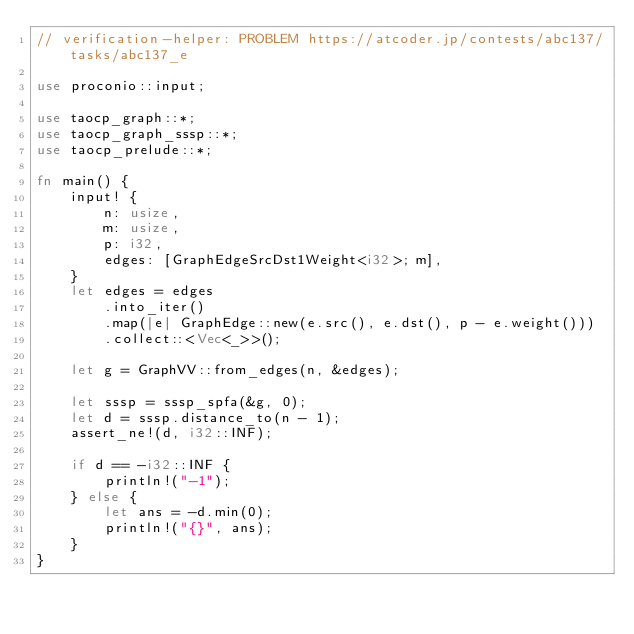<code> <loc_0><loc_0><loc_500><loc_500><_Rust_>// verification-helper: PROBLEM https://atcoder.jp/contests/abc137/tasks/abc137_e

use proconio::input;

use taocp_graph::*;
use taocp_graph_sssp::*;
use taocp_prelude::*;

fn main() {
    input! {
        n: usize,
        m: usize,
        p: i32,
        edges: [GraphEdgeSrcDst1Weight<i32>; m],
    }
    let edges = edges
        .into_iter()
        .map(|e| GraphEdge::new(e.src(), e.dst(), p - e.weight()))
        .collect::<Vec<_>>();

    let g = GraphVV::from_edges(n, &edges);

    let sssp = sssp_spfa(&g, 0);
    let d = sssp.distance_to(n - 1);
    assert_ne!(d, i32::INF);

    if d == -i32::INF {
        println!("-1");
    } else {
        let ans = -d.min(0);
        println!("{}", ans);
    }
}
</code> 